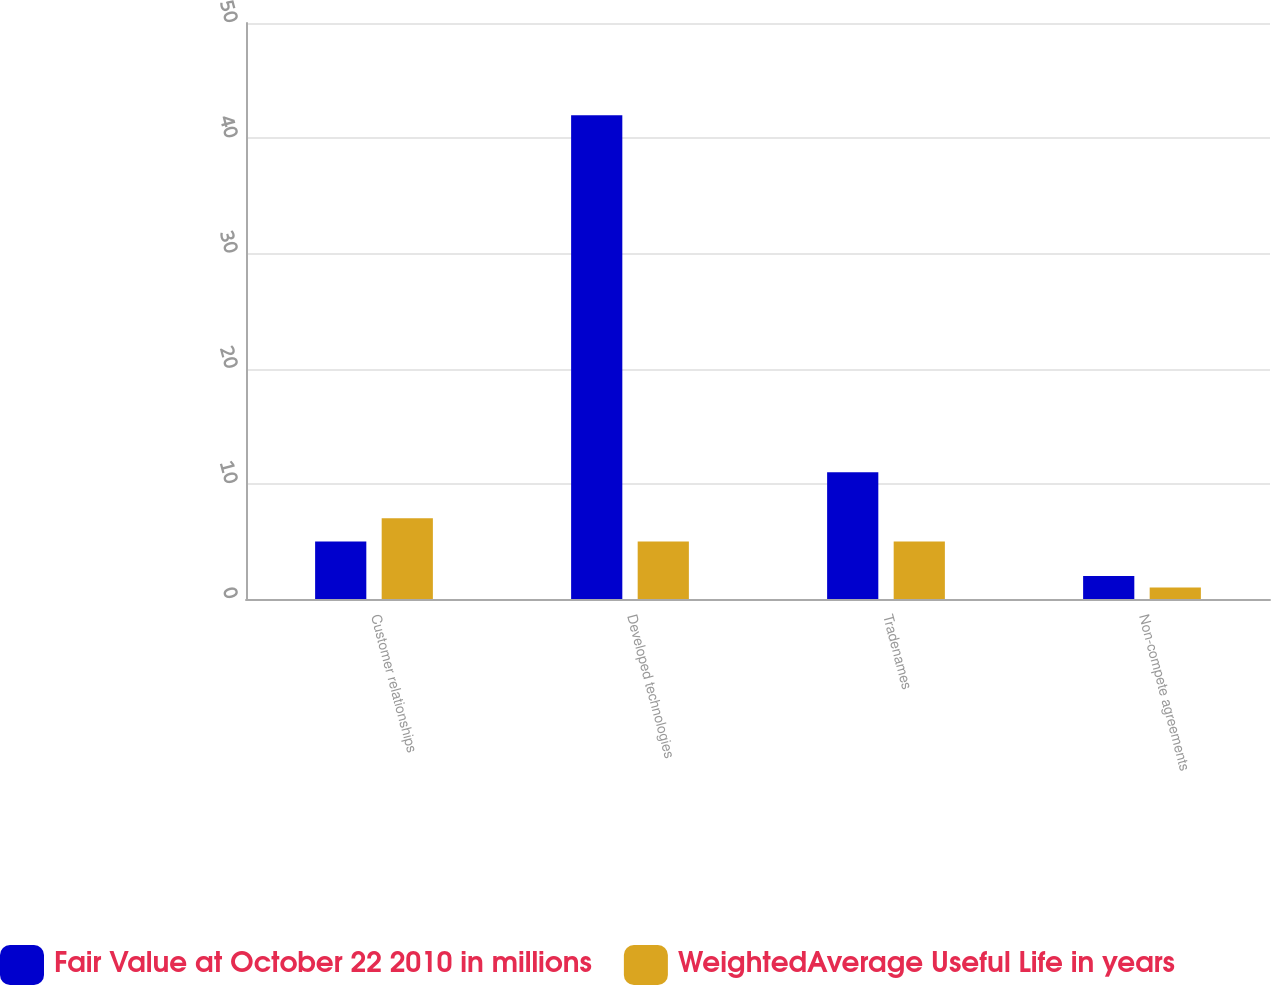Convert chart. <chart><loc_0><loc_0><loc_500><loc_500><stacked_bar_chart><ecel><fcel>Customer relationships<fcel>Developed technologies<fcel>Tradenames<fcel>Non-compete agreements<nl><fcel>Fair Value at October 22 2010 in millions<fcel>5<fcel>42<fcel>11<fcel>2<nl><fcel>WeightedAverage Useful Life in years<fcel>7<fcel>5<fcel>5<fcel>1<nl></chart> 